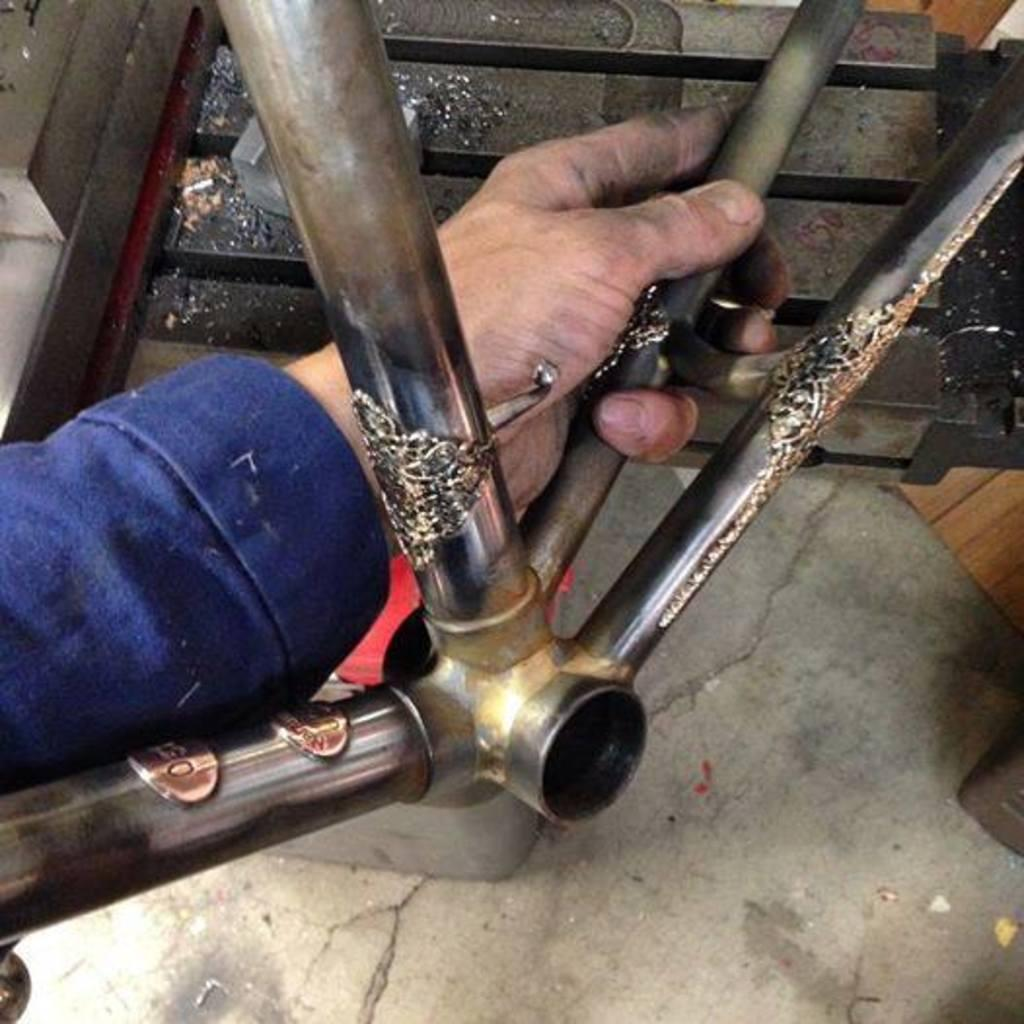What can be seen in the image related to a person's body part? There is a person's hand in the image. What is the hand holding? The hand is holding a rod. Where is the rod placed in the image? The rod is placed on the floor. What type of line can be seen connecting the hand to the breakfast in the image? There is no line connecting the hand to breakfast in the image, nor is there any breakfast present. 